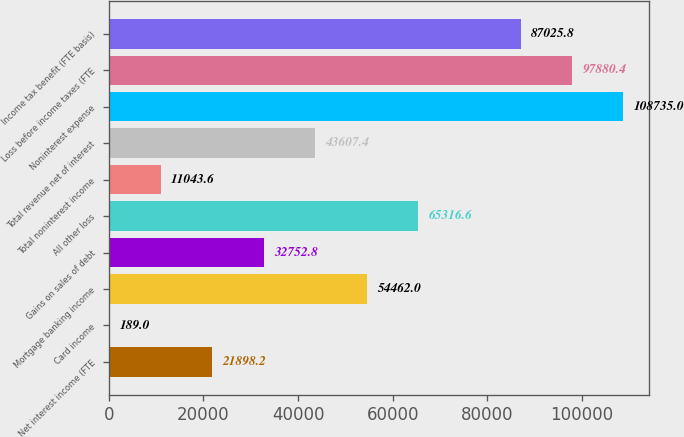Convert chart. <chart><loc_0><loc_0><loc_500><loc_500><bar_chart><fcel>Net interest income (FTE<fcel>Card income<fcel>Mortgage banking income<fcel>Gains on sales of debt<fcel>All other loss<fcel>Total noninterest income<fcel>Total revenue net of interest<fcel>Noninterest expense<fcel>Loss before income taxes (FTE<fcel>Income tax benefit (FTE basis)<nl><fcel>21898.2<fcel>189<fcel>54462<fcel>32752.8<fcel>65316.6<fcel>11043.6<fcel>43607.4<fcel>108735<fcel>97880.4<fcel>87025.8<nl></chart> 